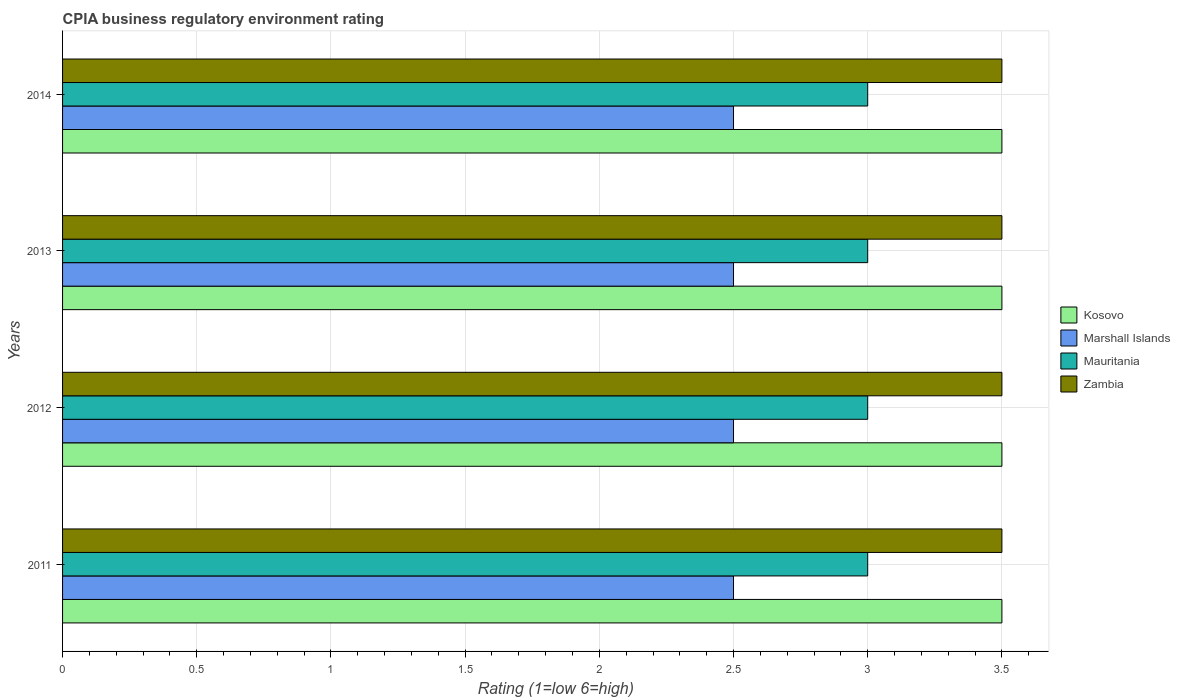Are the number of bars on each tick of the Y-axis equal?
Your answer should be very brief. Yes. How many bars are there on the 4th tick from the bottom?
Your answer should be very brief. 4. What is the label of the 4th group of bars from the top?
Your response must be concise. 2011. In which year was the CPIA rating in Kosovo minimum?
Offer a terse response. 2011. What is the difference between the CPIA rating in Zambia in 2013 and the CPIA rating in Kosovo in 2012?
Make the answer very short. 0. In the year 2012, what is the difference between the CPIA rating in Mauritania and CPIA rating in Marshall Islands?
Give a very brief answer. 0.5. What is the ratio of the CPIA rating in Kosovo in 2011 to that in 2013?
Offer a very short reply. 1. Is the CPIA rating in Marshall Islands in 2012 less than that in 2014?
Your answer should be very brief. No. What is the difference between the highest and the second highest CPIA rating in Kosovo?
Give a very brief answer. 0. Is the sum of the CPIA rating in Marshall Islands in 2013 and 2014 greater than the maximum CPIA rating in Mauritania across all years?
Your answer should be compact. Yes. Is it the case that in every year, the sum of the CPIA rating in Zambia and CPIA rating in Marshall Islands is greater than the sum of CPIA rating in Mauritania and CPIA rating in Kosovo?
Ensure brevity in your answer.  Yes. What does the 3rd bar from the top in 2012 represents?
Keep it short and to the point. Marshall Islands. What does the 4th bar from the bottom in 2013 represents?
Your response must be concise. Zambia. Is it the case that in every year, the sum of the CPIA rating in Mauritania and CPIA rating in Kosovo is greater than the CPIA rating in Zambia?
Keep it short and to the point. Yes. How many bars are there?
Provide a succinct answer. 16. Are all the bars in the graph horizontal?
Ensure brevity in your answer.  Yes. What is the difference between two consecutive major ticks on the X-axis?
Keep it short and to the point. 0.5. Does the graph contain grids?
Your response must be concise. Yes. How many legend labels are there?
Offer a very short reply. 4. How are the legend labels stacked?
Your response must be concise. Vertical. What is the title of the graph?
Make the answer very short. CPIA business regulatory environment rating. Does "Samoa" appear as one of the legend labels in the graph?
Offer a very short reply. No. What is the Rating (1=low 6=high) of Marshall Islands in 2011?
Provide a short and direct response. 2.5. What is the Rating (1=low 6=high) of Mauritania in 2011?
Your answer should be compact. 3. What is the Rating (1=low 6=high) of Zambia in 2011?
Make the answer very short. 3.5. What is the Rating (1=low 6=high) of Marshall Islands in 2012?
Make the answer very short. 2.5. What is the Rating (1=low 6=high) of Mauritania in 2012?
Your answer should be compact. 3. What is the Rating (1=low 6=high) in Zambia in 2012?
Your answer should be compact. 3.5. What is the Rating (1=low 6=high) in Zambia in 2014?
Make the answer very short. 3.5. Across all years, what is the maximum Rating (1=low 6=high) in Zambia?
Keep it short and to the point. 3.5. Across all years, what is the minimum Rating (1=low 6=high) of Zambia?
Keep it short and to the point. 3.5. What is the total Rating (1=low 6=high) in Kosovo in the graph?
Offer a terse response. 14. What is the total Rating (1=low 6=high) of Zambia in the graph?
Provide a short and direct response. 14. What is the difference between the Rating (1=low 6=high) of Marshall Islands in 2011 and that in 2012?
Offer a very short reply. 0. What is the difference between the Rating (1=low 6=high) of Mauritania in 2011 and that in 2012?
Provide a succinct answer. 0. What is the difference between the Rating (1=low 6=high) of Kosovo in 2011 and that in 2013?
Your answer should be very brief. 0. What is the difference between the Rating (1=low 6=high) of Mauritania in 2011 and that in 2013?
Your answer should be very brief. 0. What is the difference between the Rating (1=low 6=high) of Zambia in 2011 and that in 2013?
Your answer should be very brief. 0. What is the difference between the Rating (1=low 6=high) in Marshall Islands in 2011 and that in 2014?
Provide a short and direct response. 0. What is the difference between the Rating (1=low 6=high) in Zambia in 2011 and that in 2014?
Provide a succinct answer. 0. What is the difference between the Rating (1=low 6=high) of Kosovo in 2012 and that in 2013?
Provide a succinct answer. 0. What is the difference between the Rating (1=low 6=high) of Marshall Islands in 2012 and that in 2013?
Offer a very short reply. 0. What is the difference between the Rating (1=low 6=high) in Mauritania in 2012 and that in 2013?
Keep it short and to the point. 0. What is the difference between the Rating (1=low 6=high) of Zambia in 2012 and that in 2013?
Provide a short and direct response. 0. What is the difference between the Rating (1=low 6=high) of Kosovo in 2012 and that in 2014?
Make the answer very short. 0. What is the difference between the Rating (1=low 6=high) in Marshall Islands in 2012 and that in 2014?
Provide a short and direct response. 0. What is the difference between the Rating (1=low 6=high) of Kosovo in 2013 and that in 2014?
Provide a short and direct response. 0. What is the difference between the Rating (1=low 6=high) in Mauritania in 2013 and that in 2014?
Ensure brevity in your answer.  0. What is the difference between the Rating (1=low 6=high) of Zambia in 2013 and that in 2014?
Offer a very short reply. 0. What is the difference between the Rating (1=low 6=high) of Kosovo in 2011 and the Rating (1=low 6=high) of Mauritania in 2012?
Your response must be concise. 0.5. What is the difference between the Rating (1=low 6=high) of Marshall Islands in 2011 and the Rating (1=low 6=high) of Mauritania in 2012?
Ensure brevity in your answer.  -0.5. What is the difference between the Rating (1=low 6=high) of Mauritania in 2011 and the Rating (1=low 6=high) of Zambia in 2012?
Keep it short and to the point. -0.5. What is the difference between the Rating (1=low 6=high) in Kosovo in 2011 and the Rating (1=low 6=high) in Marshall Islands in 2013?
Your answer should be very brief. 1. What is the difference between the Rating (1=low 6=high) in Kosovo in 2011 and the Rating (1=low 6=high) in Mauritania in 2013?
Your response must be concise. 0.5. What is the difference between the Rating (1=low 6=high) in Marshall Islands in 2011 and the Rating (1=low 6=high) in Mauritania in 2013?
Offer a terse response. -0.5. What is the difference between the Rating (1=low 6=high) of Marshall Islands in 2011 and the Rating (1=low 6=high) of Zambia in 2013?
Offer a very short reply. -1. What is the difference between the Rating (1=low 6=high) in Kosovo in 2011 and the Rating (1=low 6=high) in Marshall Islands in 2014?
Give a very brief answer. 1. What is the difference between the Rating (1=low 6=high) in Kosovo in 2011 and the Rating (1=low 6=high) in Zambia in 2014?
Give a very brief answer. 0. What is the difference between the Rating (1=low 6=high) in Mauritania in 2011 and the Rating (1=low 6=high) in Zambia in 2014?
Your response must be concise. -0.5. What is the difference between the Rating (1=low 6=high) in Kosovo in 2012 and the Rating (1=low 6=high) in Marshall Islands in 2013?
Provide a succinct answer. 1. What is the difference between the Rating (1=low 6=high) in Marshall Islands in 2012 and the Rating (1=low 6=high) in Mauritania in 2013?
Provide a succinct answer. -0.5. What is the difference between the Rating (1=low 6=high) in Marshall Islands in 2012 and the Rating (1=low 6=high) in Zambia in 2013?
Ensure brevity in your answer.  -1. What is the difference between the Rating (1=low 6=high) of Mauritania in 2012 and the Rating (1=low 6=high) of Zambia in 2013?
Offer a terse response. -0.5. What is the difference between the Rating (1=low 6=high) of Kosovo in 2012 and the Rating (1=low 6=high) of Marshall Islands in 2014?
Your answer should be very brief. 1. What is the difference between the Rating (1=low 6=high) of Kosovo in 2012 and the Rating (1=low 6=high) of Mauritania in 2014?
Give a very brief answer. 0.5. What is the difference between the Rating (1=low 6=high) of Marshall Islands in 2012 and the Rating (1=low 6=high) of Mauritania in 2014?
Offer a terse response. -0.5. What is the difference between the Rating (1=low 6=high) in Kosovo in 2013 and the Rating (1=low 6=high) in Mauritania in 2014?
Keep it short and to the point. 0.5. What is the difference between the Rating (1=low 6=high) in Marshall Islands in 2013 and the Rating (1=low 6=high) in Mauritania in 2014?
Offer a very short reply. -0.5. What is the difference between the Rating (1=low 6=high) of Marshall Islands in 2013 and the Rating (1=low 6=high) of Zambia in 2014?
Ensure brevity in your answer.  -1. What is the average Rating (1=low 6=high) in Kosovo per year?
Ensure brevity in your answer.  3.5. What is the average Rating (1=low 6=high) in Marshall Islands per year?
Keep it short and to the point. 2.5. What is the average Rating (1=low 6=high) of Mauritania per year?
Ensure brevity in your answer.  3. What is the average Rating (1=low 6=high) of Zambia per year?
Your answer should be very brief. 3.5. In the year 2011, what is the difference between the Rating (1=low 6=high) of Kosovo and Rating (1=low 6=high) of Marshall Islands?
Offer a terse response. 1. In the year 2011, what is the difference between the Rating (1=low 6=high) of Kosovo and Rating (1=low 6=high) of Mauritania?
Make the answer very short. 0.5. In the year 2011, what is the difference between the Rating (1=low 6=high) of Kosovo and Rating (1=low 6=high) of Zambia?
Give a very brief answer. 0. In the year 2012, what is the difference between the Rating (1=low 6=high) of Kosovo and Rating (1=low 6=high) of Marshall Islands?
Give a very brief answer. 1. In the year 2012, what is the difference between the Rating (1=low 6=high) in Kosovo and Rating (1=low 6=high) in Zambia?
Your answer should be compact. 0. In the year 2012, what is the difference between the Rating (1=low 6=high) of Mauritania and Rating (1=low 6=high) of Zambia?
Your response must be concise. -0.5. In the year 2013, what is the difference between the Rating (1=low 6=high) in Kosovo and Rating (1=low 6=high) in Marshall Islands?
Ensure brevity in your answer.  1. In the year 2013, what is the difference between the Rating (1=low 6=high) in Kosovo and Rating (1=low 6=high) in Zambia?
Provide a succinct answer. 0. In the year 2013, what is the difference between the Rating (1=low 6=high) of Mauritania and Rating (1=low 6=high) of Zambia?
Your answer should be compact. -0.5. In the year 2014, what is the difference between the Rating (1=low 6=high) in Kosovo and Rating (1=low 6=high) in Marshall Islands?
Offer a terse response. 1. In the year 2014, what is the difference between the Rating (1=low 6=high) of Kosovo and Rating (1=low 6=high) of Zambia?
Your answer should be compact. 0. In the year 2014, what is the difference between the Rating (1=low 6=high) in Marshall Islands and Rating (1=low 6=high) in Mauritania?
Keep it short and to the point. -0.5. In the year 2014, what is the difference between the Rating (1=low 6=high) of Marshall Islands and Rating (1=low 6=high) of Zambia?
Offer a very short reply. -1. What is the ratio of the Rating (1=low 6=high) of Mauritania in 2011 to that in 2012?
Make the answer very short. 1. What is the ratio of the Rating (1=low 6=high) in Zambia in 2011 to that in 2012?
Make the answer very short. 1. What is the ratio of the Rating (1=low 6=high) in Marshall Islands in 2011 to that in 2013?
Give a very brief answer. 1. What is the ratio of the Rating (1=low 6=high) in Zambia in 2011 to that in 2013?
Your answer should be very brief. 1. What is the ratio of the Rating (1=low 6=high) in Marshall Islands in 2011 to that in 2014?
Offer a very short reply. 1. What is the ratio of the Rating (1=low 6=high) in Kosovo in 2012 to that in 2013?
Ensure brevity in your answer.  1. What is the ratio of the Rating (1=low 6=high) in Marshall Islands in 2012 to that in 2013?
Make the answer very short. 1. What is the ratio of the Rating (1=low 6=high) in Kosovo in 2012 to that in 2014?
Keep it short and to the point. 1. What is the ratio of the Rating (1=low 6=high) of Mauritania in 2012 to that in 2014?
Offer a very short reply. 1. What is the ratio of the Rating (1=low 6=high) in Zambia in 2012 to that in 2014?
Make the answer very short. 1. What is the ratio of the Rating (1=low 6=high) in Kosovo in 2013 to that in 2014?
Offer a terse response. 1. What is the difference between the highest and the second highest Rating (1=low 6=high) of Kosovo?
Offer a terse response. 0. What is the difference between the highest and the second highest Rating (1=low 6=high) in Marshall Islands?
Keep it short and to the point. 0. What is the difference between the highest and the second highest Rating (1=low 6=high) of Zambia?
Your answer should be very brief. 0. What is the difference between the highest and the lowest Rating (1=low 6=high) in Kosovo?
Keep it short and to the point. 0. What is the difference between the highest and the lowest Rating (1=low 6=high) in Mauritania?
Your response must be concise. 0. What is the difference between the highest and the lowest Rating (1=low 6=high) of Zambia?
Your answer should be very brief. 0. 